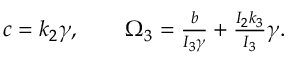<formula> <loc_0><loc_0><loc_500><loc_500>\begin{array} { r } { c = k _ { 2 } \gamma , \quad \Omega _ { 3 } = \frac { b } { I _ { 3 } \gamma } + \frac { I _ { 2 } k _ { 3 } } { I _ { 3 } } \gamma . } \end{array}</formula> 